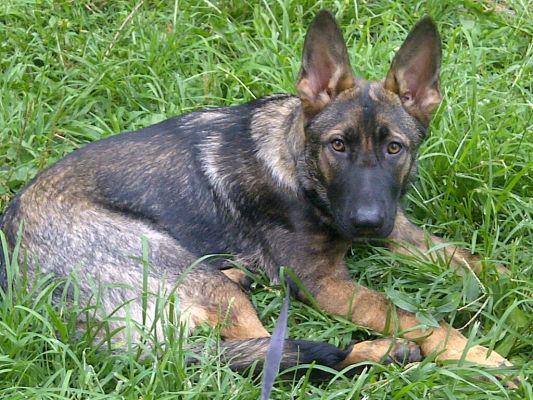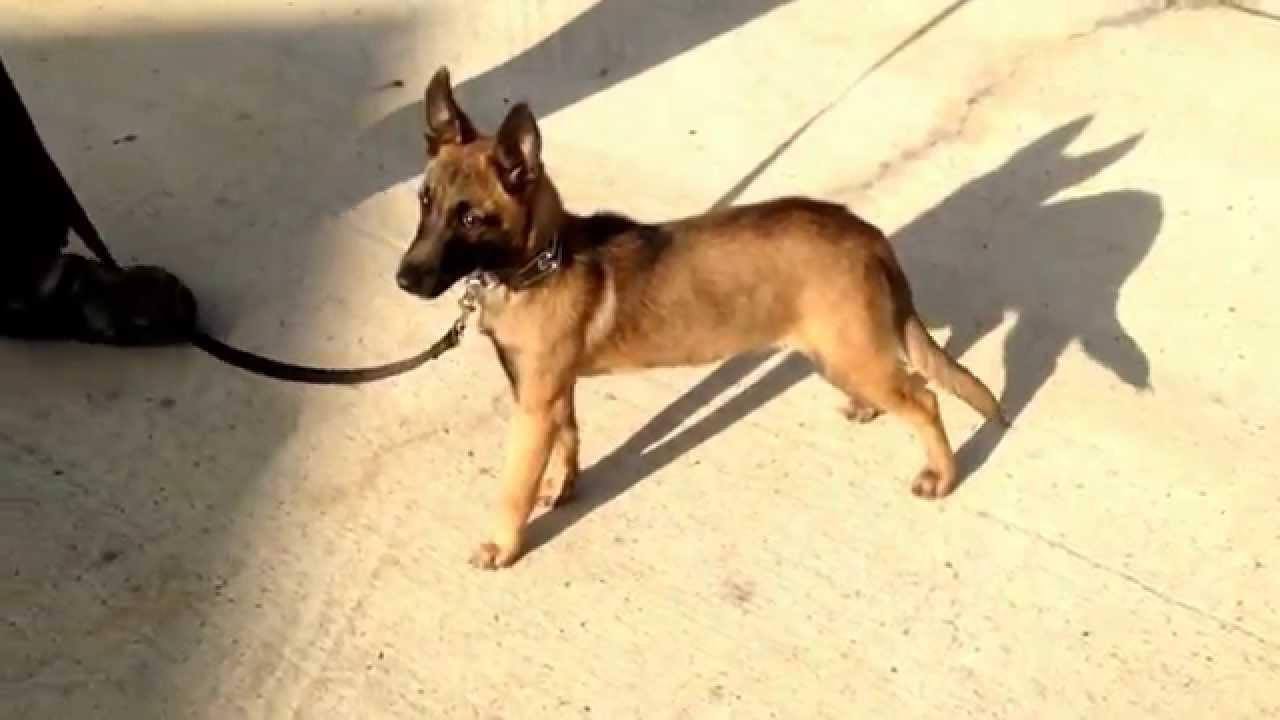The first image is the image on the left, the second image is the image on the right. Considering the images on both sides, is "An image shows exactly one german shepherd dog, which is reclining on the grass." valid? Answer yes or no. Yes. The first image is the image on the left, the second image is the image on the right. For the images displayed, is the sentence "In one of the images there is a large dog laying in the grass." factually correct? Answer yes or no. Yes. 